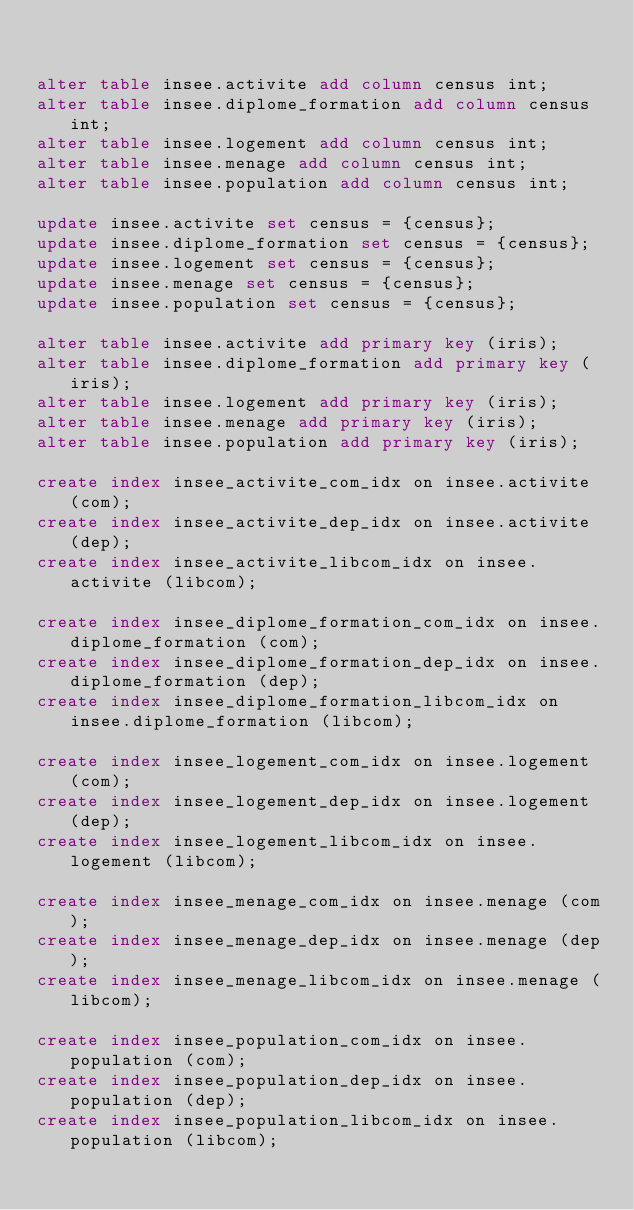<code> <loc_0><loc_0><loc_500><loc_500><_SQL_>

alter table insee.activite add column census int;
alter table insee.diplome_formation add column census int;
alter table insee.logement add column census int;
alter table insee.menage add column census int;
alter table insee.population add column census int;

update insee.activite set census = {census};
update insee.diplome_formation set census = {census};
update insee.logement set census = {census};
update insee.menage set census = {census};
update insee.population set census = {census};

alter table insee.activite add primary key (iris);
alter table insee.diplome_formation add primary key (iris);
alter table insee.logement add primary key (iris);
alter table insee.menage add primary key (iris);
alter table insee.population add primary key (iris);

create index insee_activite_com_idx on insee.activite (com);
create index insee_activite_dep_idx on insee.activite (dep);
create index insee_activite_libcom_idx on insee.activite (libcom);

create index insee_diplome_formation_com_idx on insee.diplome_formation (com);
create index insee_diplome_formation_dep_idx on insee.diplome_formation (dep);
create index insee_diplome_formation_libcom_idx on insee.diplome_formation (libcom);

create index insee_logement_com_idx on insee.logement (com);
create index insee_logement_dep_idx on insee.logement (dep);
create index insee_logement_libcom_idx on insee.logement (libcom);

create index insee_menage_com_idx on insee.menage (com);
create index insee_menage_dep_idx on insee.menage (dep);
create index insee_menage_libcom_idx on insee.menage (libcom);

create index insee_population_com_idx on insee.population (com);
create index insee_population_dep_idx on insee.population (dep);
create index insee_population_libcom_idx on insee.population (libcom);

</code> 